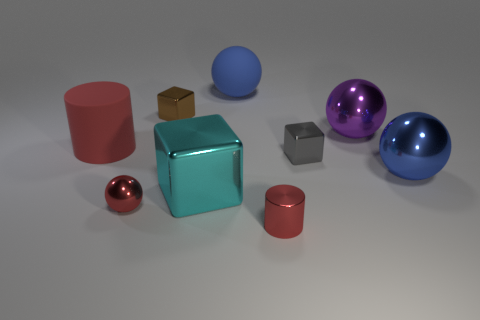What are the different materials that the objects in the image appear to be made of? The objects in the image display a variety of textures indicative of different materials. Some objects have a matte finish resembling rubber or plastic, while others are reflective, suggesting they are metallic. Overall, we can deduce a presence of rubber, metal, and possibly some plastic materials. 